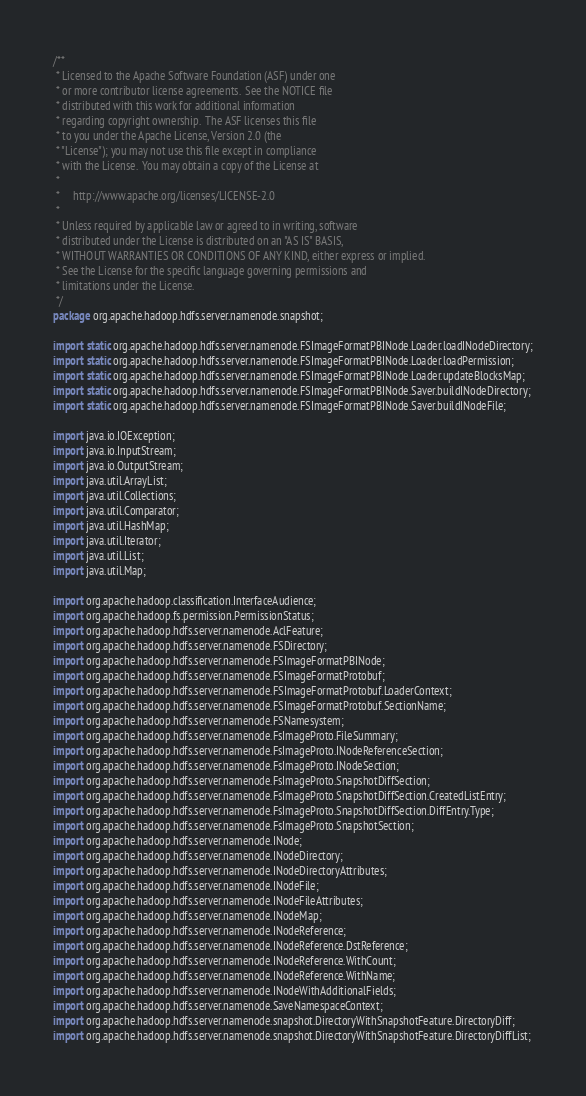<code> <loc_0><loc_0><loc_500><loc_500><_Java_>/**
 * Licensed to the Apache Software Foundation (ASF) under one
 * or more contributor license agreements.  See the NOTICE file
 * distributed with this work for additional information
 * regarding copyright ownership.  The ASF licenses this file
 * to you under the Apache License, Version 2.0 (the
 * "License"); you may not use this file except in compliance
 * with the License.  You may obtain a copy of the License at
 *
 *     http://www.apache.org/licenses/LICENSE-2.0
 *
 * Unless required by applicable law or agreed to in writing, software
 * distributed under the License is distributed on an "AS IS" BASIS,
 * WITHOUT WARRANTIES OR CONDITIONS OF ANY KIND, either express or implied.
 * See the License for the specific language governing permissions and
 * limitations under the License.
 */
package org.apache.hadoop.hdfs.server.namenode.snapshot;

import static org.apache.hadoop.hdfs.server.namenode.FSImageFormatPBINode.Loader.loadINodeDirectory;
import static org.apache.hadoop.hdfs.server.namenode.FSImageFormatPBINode.Loader.loadPermission;
import static org.apache.hadoop.hdfs.server.namenode.FSImageFormatPBINode.Loader.updateBlocksMap;
import static org.apache.hadoop.hdfs.server.namenode.FSImageFormatPBINode.Saver.buildINodeDirectory;
import static org.apache.hadoop.hdfs.server.namenode.FSImageFormatPBINode.Saver.buildINodeFile;

import java.io.IOException;
import java.io.InputStream;
import java.io.OutputStream;
import java.util.ArrayList;
import java.util.Collections;
import java.util.Comparator;
import java.util.HashMap;
import java.util.Iterator;
import java.util.List;
import java.util.Map;

import org.apache.hadoop.classification.InterfaceAudience;
import org.apache.hadoop.fs.permission.PermissionStatus;
import org.apache.hadoop.hdfs.server.namenode.AclFeature;
import org.apache.hadoop.hdfs.server.namenode.FSDirectory;
import org.apache.hadoop.hdfs.server.namenode.FSImageFormatPBINode;
import org.apache.hadoop.hdfs.server.namenode.FSImageFormatProtobuf;
import org.apache.hadoop.hdfs.server.namenode.FSImageFormatProtobuf.LoaderContext;
import org.apache.hadoop.hdfs.server.namenode.FSImageFormatProtobuf.SectionName;
import org.apache.hadoop.hdfs.server.namenode.FSNamesystem;
import org.apache.hadoop.hdfs.server.namenode.FsImageProto.FileSummary;
import org.apache.hadoop.hdfs.server.namenode.FsImageProto.INodeReferenceSection;
import org.apache.hadoop.hdfs.server.namenode.FsImageProto.INodeSection;
import org.apache.hadoop.hdfs.server.namenode.FsImageProto.SnapshotDiffSection;
import org.apache.hadoop.hdfs.server.namenode.FsImageProto.SnapshotDiffSection.CreatedListEntry;
import org.apache.hadoop.hdfs.server.namenode.FsImageProto.SnapshotDiffSection.DiffEntry.Type;
import org.apache.hadoop.hdfs.server.namenode.FsImageProto.SnapshotSection;
import org.apache.hadoop.hdfs.server.namenode.INode;
import org.apache.hadoop.hdfs.server.namenode.INodeDirectory;
import org.apache.hadoop.hdfs.server.namenode.INodeDirectoryAttributes;
import org.apache.hadoop.hdfs.server.namenode.INodeFile;
import org.apache.hadoop.hdfs.server.namenode.INodeFileAttributes;
import org.apache.hadoop.hdfs.server.namenode.INodeMap;
import org.apache.hadoop.hdfs.server.namenode.INodeReference;
import org.apache.hadoop.hdfs.server.namenode.INodeReference.DstReference;
import org.apache.hadoop.hdfs.server.namenode.INodeReference.WithCount;
import org.apache.hadoop.hdfs.server.namenode.INodeReference.WithName;
import org.apache.hadoop.hdfs.server.namenode.INodeWithAdditionalFields;
import org.apache.hadoop.hdfs.server.namenode.SaveNamespaceContext;
import org.apache.hadoop.hdfs.server.namenode.snapshot.DirectoryWithSnapshotFeature.DirectoryDiff;
import org.apache.hadoop.hdfs.server.namenode.snapshot.DirectoryWithSnapshotFeature.DirectoryDiffList;</code> 